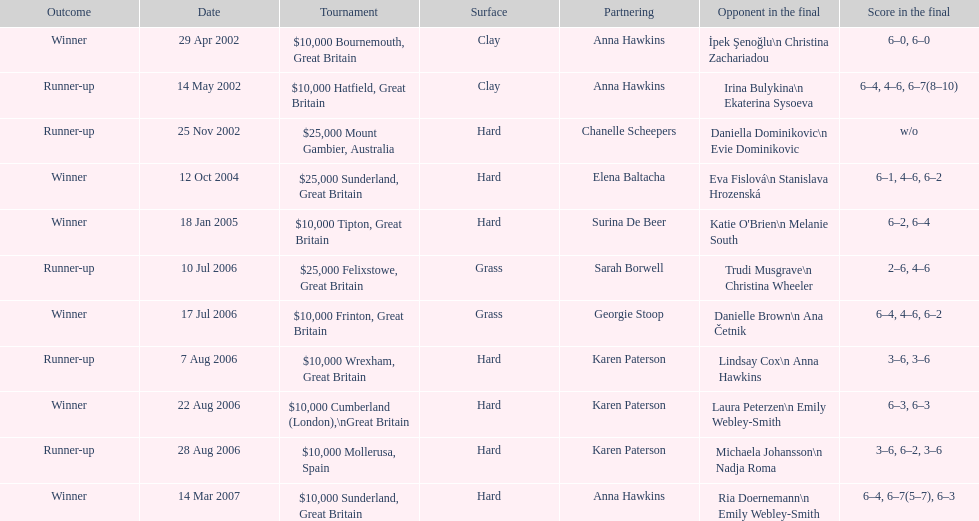What is the number of games played on a hard surface? 7. Could you parse the entire table? {'header': ['Outcome', 'Date', 'Tournament', 'Surface', 'Partnering', 'Opponent in the final', 'Score in the final'], 'rows': [['Winner', '29 Apr 2002', '$10,000 Bournemouth, Great Britain', 'Clay', 'Anna Hawkins', 'İpek Şenoğlu\\n Christina Zachariadou', '6–0, 6–0'], ['Runner-up', '14 May 2002', '$10,000 Hatfield, Great Britain', 'Clay', 'Anna Hawkins', 'Irina Bulykina\\n Ekaterina Sysoeva', '6–4, 4–6, 6–7(8–10)'], ['Runner-up', '25 Nov 2002', '$25,000 Mount Gambier, Australia', 'Hard', 'Chanelle Scheepers', 'Daniella Dominikovic\\n Evie Dominikovic', 'w/o'], ['Winner', '12 Oct 2004', '$25,000 Sunderland, Great Britain', 'Hard', 'Elena Baltacha', 'Eva Fislová\\n Stanislava Hrozenská', '6–1, 4–6, 6–2'], ['Winner', '18 Jan 2005', '$10,000 Tipton, Great Britain', 'Hard', 'Surina De Beer', "Katie O'Brien\\n Melanie South", '6–2, 6–4'], ['Runner-up', '10 Jul 2006', '$25,000 Felixstowe, Great Britain', 'Grass', 'Sarah Borwell', 'Trudi Musgrave\\n Christina Wheeler', '2–6, 4–6'], ['Winner', '17 Jul 2006', '$10,000 Frinton, Great Britain', 'Grass', 'Georgie Stoop', 'Danielle Brown\\n Ana Četnik', '6–4, 4–6, 6–2'], ['Runner-up', '7 Aug 2006', '$10,000 Wrexham, Great Britain', 'Hard', 'Karen Paterson', 'Lindsay Cox\\n Anna Hawkins', '3–6, 3–6'], ['Winner', '22 Aug 2006', '$10,000 Cumberland (London),\\nGreat Britain', 'Hard', 'Karen Paterson', 'Laura Peterzen\\n Emily Webley-Smith', '6–3, 6–3'], ['Runner-up', '28 Aug 2006', '$10,000 Mollerusa, Spain', 'Hard', 'Karen Paterson', 'Michaela Johansson\\n Nadja Roma', '3–6, 6–2, 3–6'], ['Winner', '14 Mar 2007', '$10,000 Sunderland, Great Britain', 'Hard', 'Anna Hawkins', 'Ria Doernemann\\n Emily Webley-Smith', '6–4, 6–7(5–7), 6–3']]} 